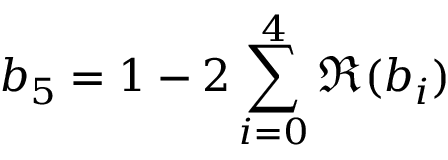<formula> <loc_0><loc_0><loc_500><loc_500>b _ { 5 } = 1 - 2 \sum _ { i = 0 } ^ { 4 } \Re ( b _ { i } )</formula> 